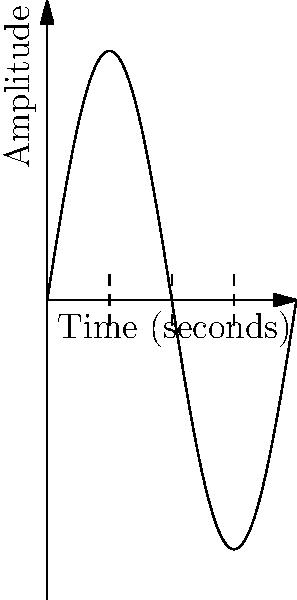As a former drummer, you're analyzing a waveform of a bass drum hit. The graph shows one second of the waveform. If the vertical dashed lines represent the start of each beat, what is the tempo of this rhythm in beats per minute (BPM)? To calculate the tempo in BPM, we need to follow these steps:

1. Count the number of complete beats in the given time frame:
   The graph shows 4 dashed lines, representing the start of 4 beats.

2. Determine the time duration of the sample:
   The x-axis shows 1 second of the waveform.

3. Calculate beats per second:
   Beats per second = Number of beats / Time duration
   $$ \text{Beats per second} = \frac{4 \text{ beats}}{1 \text{ second}} = 4 \text{ beats/second} $$

4. Convert beats per second to beats per minute:
   Multiply the beats per second by 60 (number of seconds in a minute)
   $$ \text{BPM} = 4 \text{ beats/second} \times 60 \text{ seconds/minute} = 240 \text{ BPM} $$

Therefore, the tempo of this rhythm is 240 BPM.
Answer: 240 BPM 